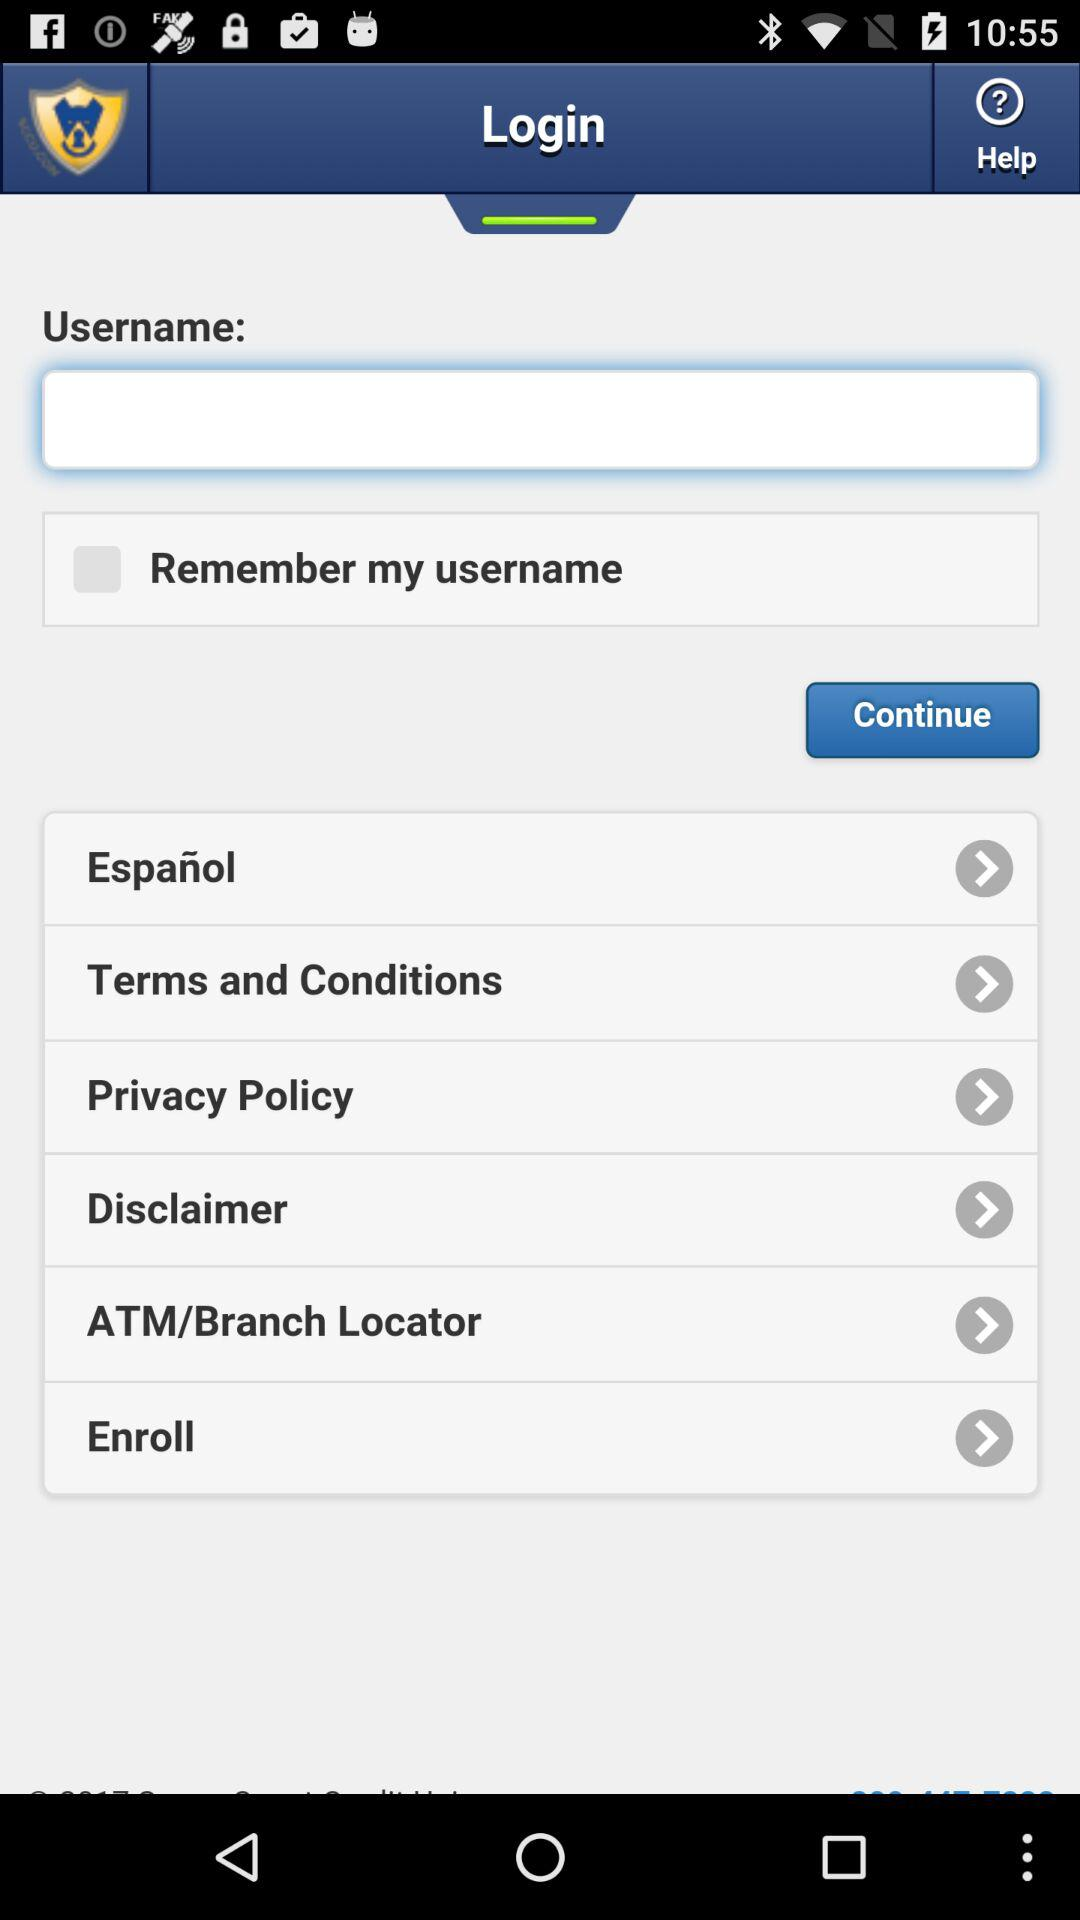How many text inputs are on the screen?
Answer the question using a single word or phrase. 1 